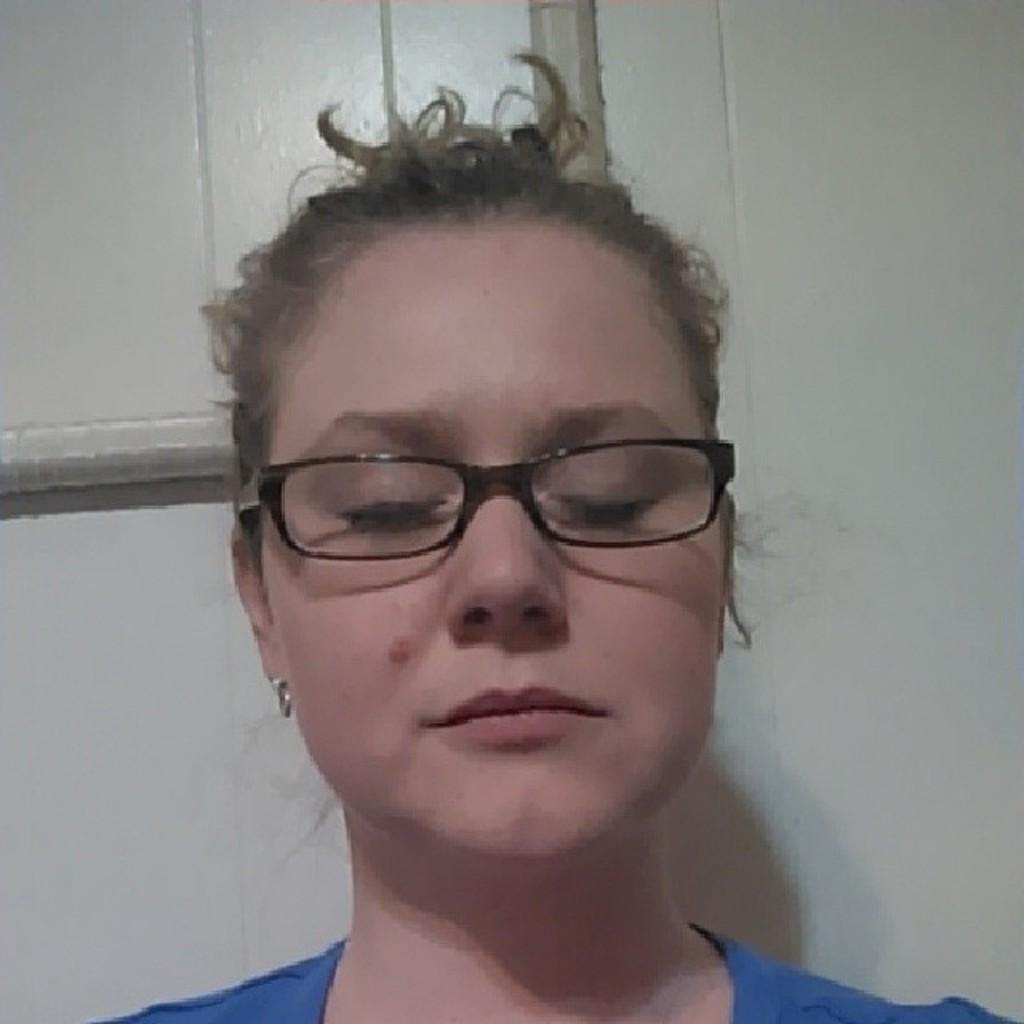Who is the main subject in the image? There is a woman in the image. What is the woman wearing? The woman is wearing a blue shirt. Are there any accessories visible on the woman? Yes, the woman has spectacles. What can be seen in the background of the image? There is a white wall in the background of the image. What type of advertisement is displayed on the woman's shirt in the image? There is no advertisement displayed on the woman's shirt in the image; she is wearing a blue shirt without any visible advertisements. 